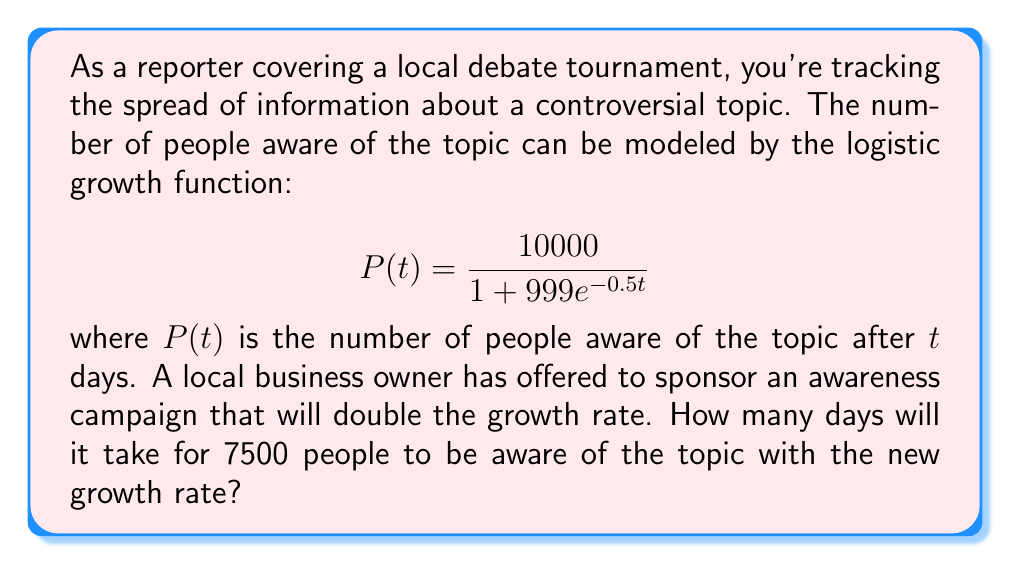Show me your answer to this math problem. To solve this problem, we need to follow these steps:

1) First, let's understand the given function:
   $$P(t) = \frac{10000}{1 + 999e^{-0.5t}}$$
   Here, 10000 is the carrying capacity (maximum number of people who can be aware),
   and 0.5 is the growth rate.

2) The business owner's sponsorship doubles the growth rate. So, the new function will be:
   $$P(t) = \frac{10000}{1 + 999e^{-1t}}$$

3) We need to find $t$ when $P(t) = 7500$. Let's set up the equation:
   $$7500 = \frac{10000}{1 + 999e^{-t}}$$

4) Multiply both sides by $(1 + 999e^{-t})$:
   $$7500(1 + 999e^{-t}) = 10000$$

5) Expand:
   $$7500 + 7499500e^{-t} = 10000$$

6) Subtract 7500 from both sides:
   $$7499500e^{-t} = 2500$$

7) Divide both sides by 7499500:
   $$e^{-t} = \frac{1}{2999.8}$$

8) Take the natural log of both sides:
   $$-t = \ln(\frac{1}{2999.8}) = -\ln(2999.8)$$

9) Solve for $t$:
   $$t = \ln(2999.8) \approx 8.006$$

Therefore, it will take approximately 8.006 days for 7500 people to be aware of the topic with the new growth rate.
Answer: 8.006 days 